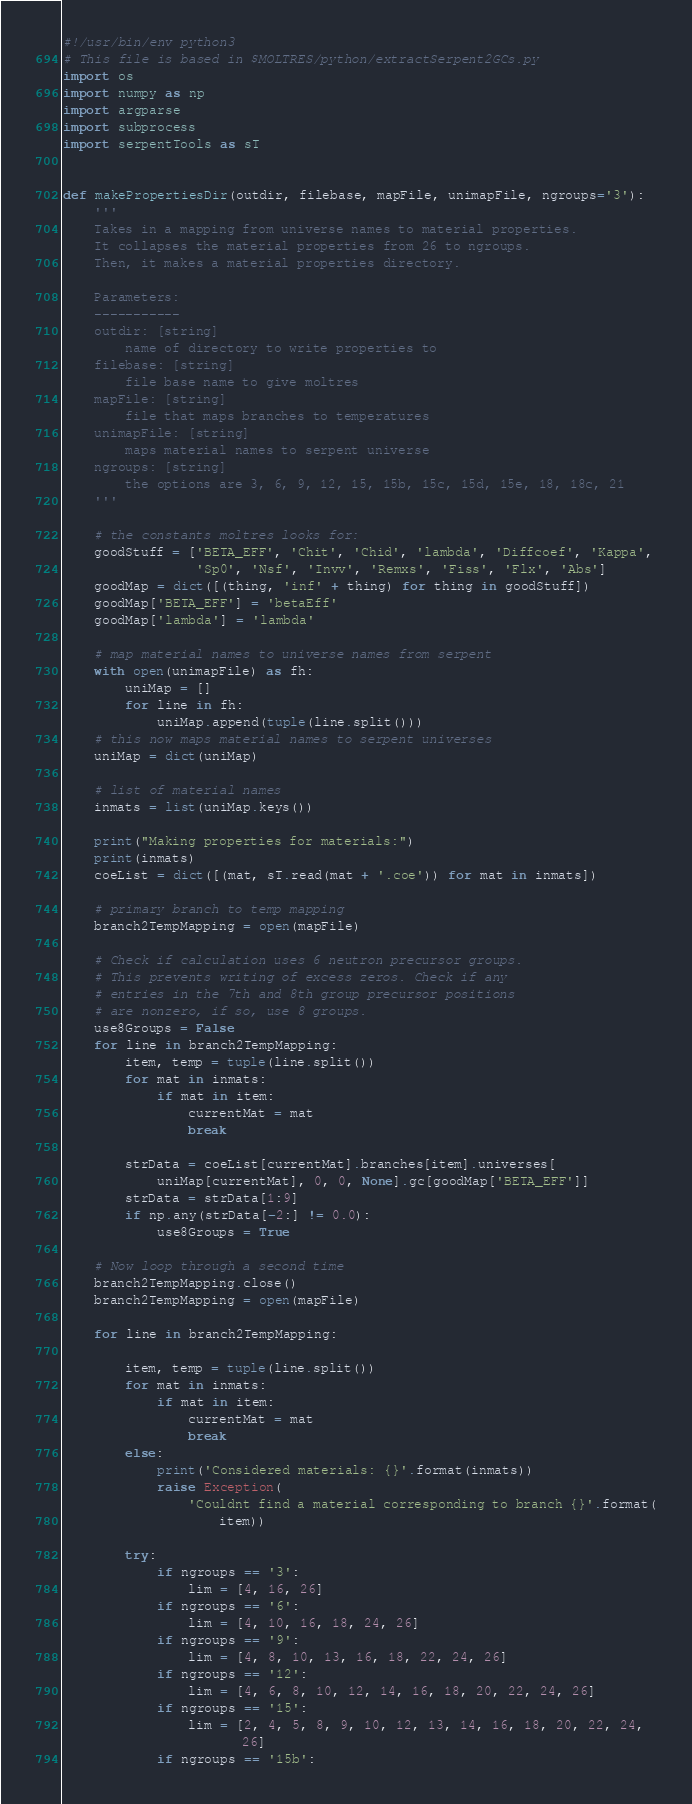Convert code to text. <code><loc_0><loc_0><loc_500><loc_500><_Python_>#!/usr/bin/env python3
# This file is based in $MOLTRES/python/extractSerpent2GCs.py
import os
import numpy as np
import argparse
import subprocess
import serpentTools as sT


def makePropertiesDir(outdir, filebase, mapFile, unimapFile, ngroups='3'):
    '''
    Takes in a mapping from universe names to material properties.
    It collapses the material properties from 26 to ngroups.
    Then, it makes a material properties directory.

    Parameters:
    -----------
    outdir: [string]
        name of directory to write properties to
    filebase: [string]
        file base name to give moltres
    mapFile: [string]
        file that maps branches to temperatures
    unimapFile: [string]
        maps material names to serpent universe
    ngroups: [string]
        the options are 3, 6, 9, 12, 15, 15b, 15c, 15d, 15e, 18, 18c, 21
    '''

    # the constants moltres looks for:
    goodStuff = ['BETA_EFF', 'Chit', 'Chid', 'lambda', 'Diffcoef', 'Kappa',
                 'Sp0', 'Nsf', 'Invv', 'Remxs', 'Fiss', 'Flx', 'Abs']
    goodMap = dict([(thing, 'inf' + thing) for thing in goodStuff])
    goodMap['BETA_EFF'] = 'betaEff'
    goodMap['lambda'] = 'lambda'

    # map material names to universe names from serpent
    with open(unimapFile) as fh:
        uniMap = []
        for line in fh:
            uniMap.append(tuple(line.split()))
    # this now maps material names to serpent universes
    uniMap = dict(uniMap)

    # list of material names
    inmats = list(uniMap.keys())

    print("Making properties for materials:")
    print(inmats)
    coeList = dict([(mat, sT.read(mat + '.coe')) for mat in inmats])

    # primary branch to temp mapping
    branch2TempMapping = open(mapFile)

    # Check if calculation uses 6 neutron precursor groups.
    # This prevents writing of excess zeros. Check if any
    # entries in the 7th and 8th group precursor positions
    # are nonzero, if so, use 8 groups.
    use8Groups = False
    for line in branch2TempMapping:
        item, temp = tuple(line.split())
        for mat in inmats:
            if mat in item:
                currentMat = mat
                break

        strData = coeList[currentMat].branches[item].universes[
            uniMap[currentMat], 0, 0, None].gc[goodMap['BETA_EFF']]
        strData = strData[1:9]
        if np.any(strData[-2:] != 0.0):
            use8Groups = True

    # Now loop through a second time
    branch2TempMapping.close()
    branch2TempMapping = open(mapFile)

    for line in branch2TempMapping:

        item, temp = tuple(line.split())
        for mat in inmats:
            if mat in item:
                currentMat = mat
                break
        else:
            print('Considered materials: {}'.format(inmats))
            raise Exception(
                'Couldnt find a material corresponding to branch {}'.format(
                    item))

        try:
            if ngroups == '3':
                lim = [4, 16, 26]
            if ngroups == '6':
                lim = [4, 10, 16, 18, 24, 26]
            if ngroups == '9':
                lim = [4, 8, 10, 13, 16, 18, 22, 24, 26]
            if ngroups == '12':
                lim = [4, 6, 8, 10, 12, 14, 16, 18, 20, 22, 24, 26]
            if ngroups == '15':
                lim = [2, 4, 5, 8, 9, 10, 12, 13, 14, 16, 18, 20, 22, 24,
                       26]
            if ngroups == '15b':</code> 